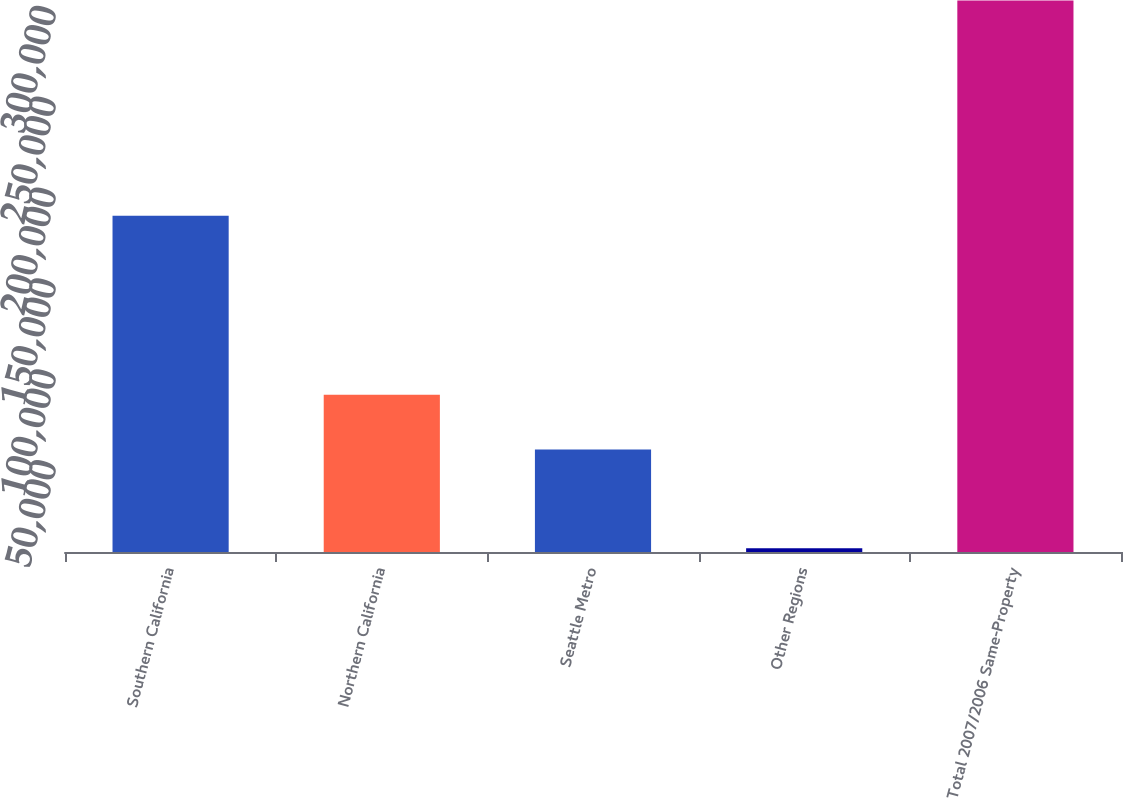Convert chart. <chart><loc_0><loc_0><loc_500><loc_500><bar_chart><fcel>Southern California<fcel>Northern California<fcel>Seattle Metro<fcel>Other Regions<fcel>Total 2007/2006 Same-Property<nl><fcel>185060<fcel>86578.1<fcel>56427<fcel>2015<fcel>303526<nl></chart> 